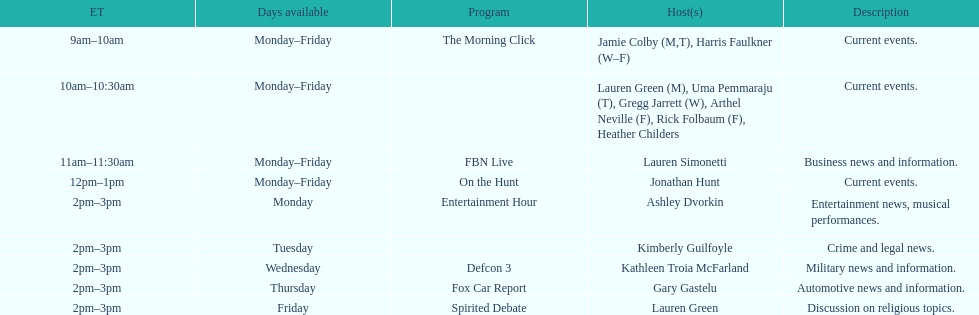Who are all of the hosts? Jamie Colby (M,T), Harris Faulkner (W–F), Lauren Green (M), Uma Pemmaraju (T), Gregg Jarrett (W), Arthel Neville (F), Rick Folbaum (F), Heather Childers, Lauren Simonetti, Jonathan Hunt, Ashley Dvorkin, Kimberly Guilfoyle, Kathleen Troia McFarland, Gary Gastelu, Lauren Green. Which hosts have shows on fridays? Jamie Colby (M,T), Harris Faulkner (W–F), Lauren Green (M), Uma Pemmaraju (T), Gregg Jarrett (W), Arthel Neville (F), Rick Folbaum (F), Heather Childers, Lauren Simonetti, Jonathan Hunt, Lauren Green. Of those, which host's show airs at 2pm? Lauren Green. 